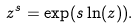Convert formula to latex. <formula><loc_0><loc_0><loc_500><loc_500>z ^ { s } = \exp ( s \ln ( z ) ) .</formula> 